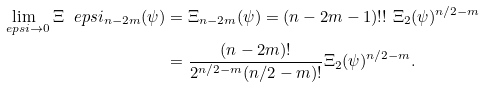Convert formula to latex. <formula><loc_0><loc_0><loc_500><loc_500>\lim _ { \ e p s i \rightarrow 0 } \Xi ^ { \ } e p s i _ { n - 2 m } ( \psi ) & = \Xi _ { n - 2 m } ( \psi ) = ( n - 2 m - 1 ) ! ! \ \Xi _ { 2 } ( \psi ) ^ { n / 2 - m } \\ & = \frac { ( n - 2 m ) ! } { 2 ^ { n / 2 - m } ( n / 2 - m ) ! } \Xi _ { 2 } ( \psi ) ^ { n / 2 - m } .</formula> 